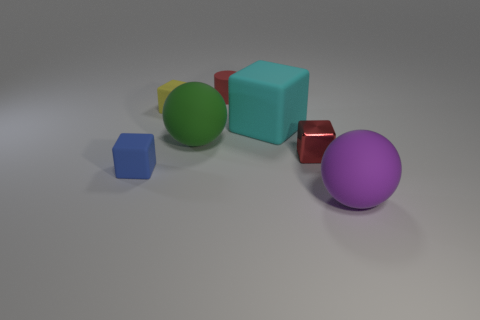What number of objects are either balls on the right side of the large cube or tiny green matte cylinders?
Your response must be concise. 1. Does the green object have the same size as the purple matte object?
Your answer should be compact. Yes. There is a rubber thing that is behind the small yellow cube; what is its color?
Your answer should be compact. Red. What is the size of the green sphere that is the same material as the cylinder?
Your response must be concise. Large. There is a blue matte cube; is it the same size as the matte ball left of the red metallic block?
Ensure brevity in your answer.  No. There is a small cube in front of the tiny red shiny block; what material is it?
Offer a very short reply. Rubber. There is a small yellow object that is behind the large purple thing; how many blue matte blocks are left of it?
Your answer should be compact. 1. Is there another thing that has the same shape as the large green thing?
Make the answer very short. Yes. There is a red thing that is behind the large green ball; is its size the same as the ball that is to the left of the red matte cylinder?
Ensure brevity in your answer.  No. The small red thing that is on the left side of the small red thing in front of the large green rubber ball is what shape?
Keep it short and to the point. Cylinder. 